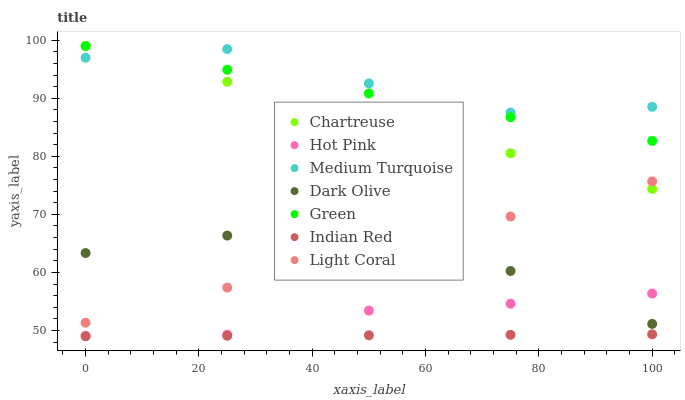Does Indian Red have the minimum area under the curve?
Answer yes or no. Yes. Does Medium Turquoise have the maximum area under the curve?
Answer yes or no. Yes. Does Dark Olive have the minimum area under the curve?
Answer yes or no. No. Does Dark Olive have the maximum area under the curve?
Answer yes or no. No. Is Indian Red the smoothest?
Answer yes or no. Yes. Is Medium Turquoise the roughest?
Answer yes or no. Yes. Is Dark Olive the smoothest?
Answer yes or no. No. Is Dark Olive the roughest?
Answer yes or no. No. Does Indian Red have the lowest value?
Answer yes or no. Yes. Does Dark Olive have the lowest value?
Answer yes or no. No. Does Green have the highest value?
Answer yes or no. Yes. Does Medium Turquoise have the highest value?
Answer yes or no. No. Is Hot Pink less than Green?
Answer yes or no. Yes. Is Green greater than Light Coral?
Answer yes or no. Yes. Does Light Coral intersect Dark Olive?
Answer yes or no. Yes. Is Light Coral less than Dark Olive?
Answer yes or no. No. Is Light Coral greater than Dark Olive?
Answer yes or no. No. Does Hot Pink intersect Green?
Answer yes or no. No. 